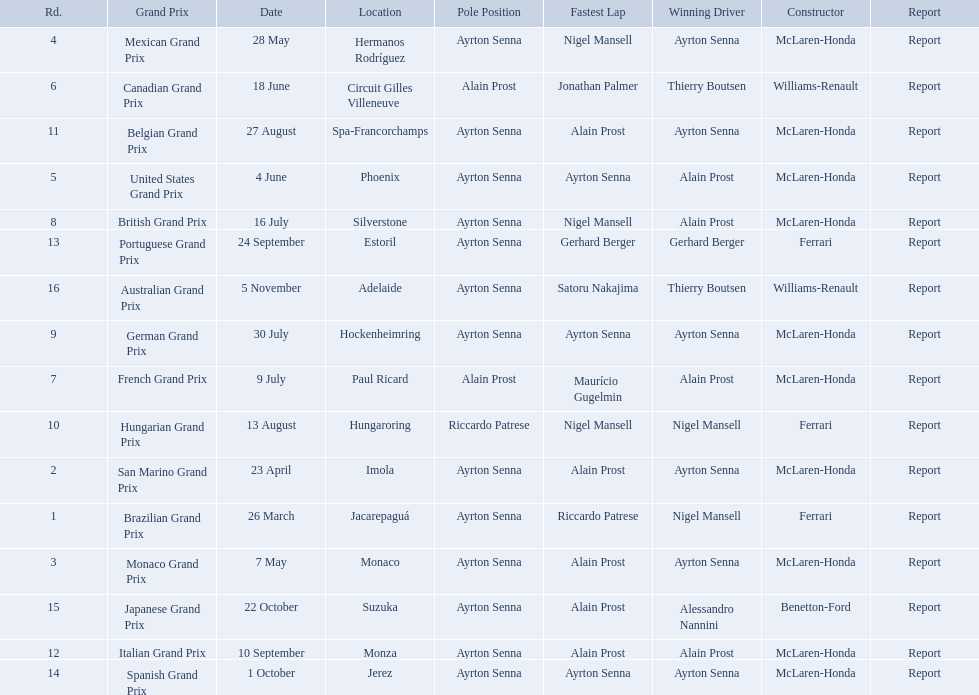Who won the spanish grand prix? McLaren-Honda. Who won the italian grand prix? McLaren-Honda. What grand prix did benneton-ford win? Japanese Grand Prix. 